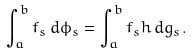<formula> <loc_0><loc_0><loc_500><loc_500>\int _ { a } ^ { b } f _ { s } \, d \phi _ { s } = \int _ { a } ^ { b } f _ { s } h \, d g _ { s } .</formula> 